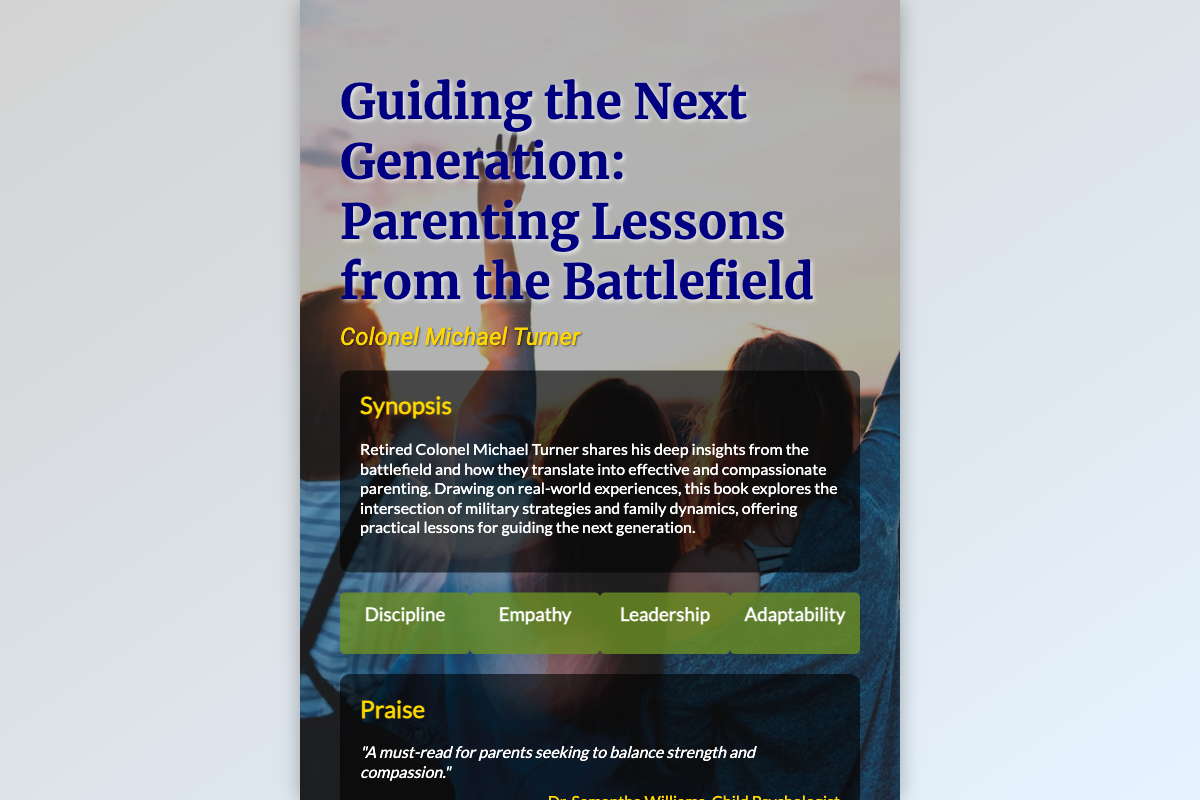What is the title of the book? The title of the book is prominently displayed at the top of the cover.
Answer: Guiding the Next Generation: Parenting Lessons from the Battlefield Who is the author of the book? The author's name is presented just below the title in a different font style.
Answer: Colonel Michael Turner What colors are used in the book cover's background? The background features a gradient of colors that can be identified visually.
Answer: Light gray and light blue Which theme focuses on flexibility? One of the themes listed relates to adjusting to different situations.
Answer: Adaptability What type of feedback does Dr. Samantha Williams give about the book? The feedback is a praise quote attributed to a professional in child psychology.
Answer: A must-read for parents seeking to balance strength and compassion How many main themes are presented on the cover? The number of themes is represented as separate boxes on the book cover.
Answer: Four What is the background image's effect on the text? The background image has a visual filter applied to enhance readability.
Answer: It is filtered for brightness What profession does Jane Foster belong to? The document indicates her affiliation through her title in the praise section.
Answer: Parenting Blogger 